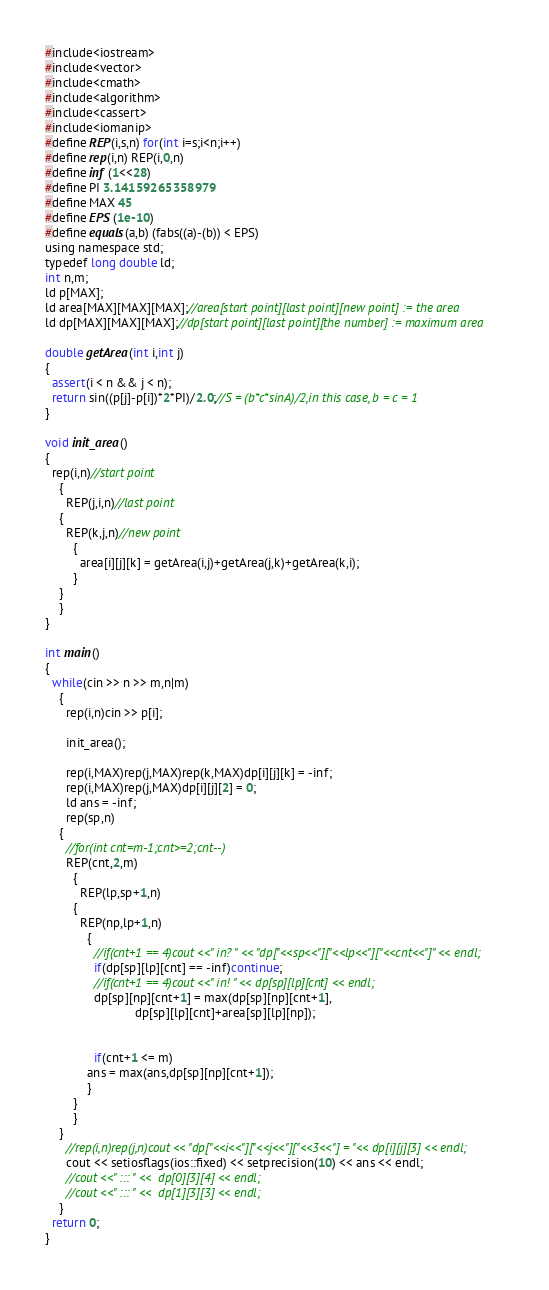<code> <loc_0><loc_0><loc_500><loc_500><_Java_>#include<iostream>
#include<vector>
#include<cmath>
#include<algorithm>
#include<cassert>
#include<iomanip>
#define REP(i,s,n) for(int i=s;i<n;i++)
#define rep(i,n) REP(i,0,n)
#define inf (1<<28)
#define PI 3.14159265358979
#define MAX 45
#define EPS (1e-10)
#define equals(a,b) (fabs((a)-(b)) < EPS)
using namespace std;
typedef long double ld;
int n,m;
ld p[MAX];
ld area[MAX][MAX][MAX];//area[start point][last point][new point] := the area
ld dp[MAX][MAX][MAX];//dp[start point][last point][the number] := maximum area

double getArea(int i,int j)
{
  assert(i < n && j < n);
  return sin((p[j]-p[i])*2*PI)/2.0;//S = (b*c*sinA)/2,in this case, b = c = 1
}

void init_area()
{
  rep(i,n)//start point
    {
      REP(j,i,n)//last point
	{
	  REP(k,j,n)//new point
	    {
	      area[i][j][k] = getArea(i,j)+getArea(j,k)+getArea(k,i);
	    }
	}
    }
}

int main()
{
  while(cin >> n >> m,n|m)
    {
      rep(i,n)cin >> p[i];

      init_area();

      rep(i,MAX)rep(j,MAX)rep(k,MAX)dp[i][j][k] = -inf;
      rep(i,MAX)rep(j,MAX)dp[i][j][2] = 0;
      ld ans = -inf;
      rep(sp,n)
	{
	  //for(int cnt=m-1;cnt>=2;cnt--)
	  REP(cnt,2,m)
	    {
	      REP(lp,sp+1,n)
		{
		  REP(np,lp+1,n)
		    {
		      //if(cnt+1 == 4)cout <<" in? " << "dp["<<sp<<"]["<<lp<<"]["<<cnt<<"]" << endl;
		      if(dp[sp][lp][cnt] == -inf)continue;
		      //if(cnt+1 == 4)cout <<" in! " << dp[sp][lp][cnt] << endl;
		      dp[sp][np][cnt+1] = max(dp[sp][np][cnt+1],
					      dp[sp][lp][cnt]+area[sp][lp][np]);
	
		     
		      if(cnt+1 <= m)
			ans = max(ans,dp[sp][np][cnt+1]);  
		    }
		}
	    }
	}
      //rep(i,n)rep(j,n)cout << "dp["<<i<<"]["<<j<<"]["<<3<<"] = "<< dp[i][j][3] << endl;
      cout << setiosflags(ios::fixed) << setprecision(10) << ans << endl;
      //cout <<" ::: " <<  dp[0][3][4] << endl;
      //cout <<" ::: " <<  dp[1][3][3] << endl;
    }
  return 0;
}</code> 